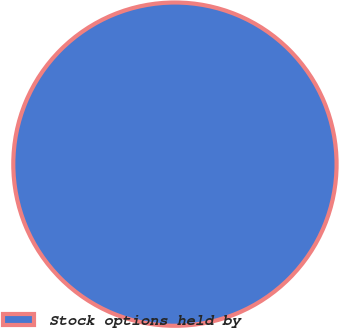<chart> <loc_0><loc_0><loc_500><loc_500><pie_chart><fcel>Stock options held by<nl><fcel>100.0%<nl></chart> 